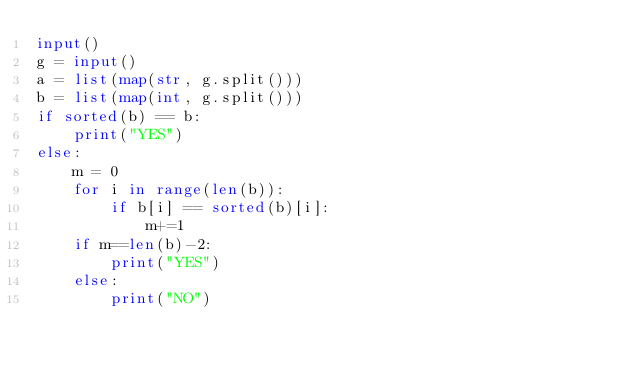<code> <loc_0><loc_0><loc_500><loc_500><_Python_>input()
g = input()
a = list(map(str, g.split()))
b = list(map(int, g.split()))
if sorted(b) == b:
    print("YES")
else:
    m = 0
    for i in range(len(b)):
        if b[i] == sorted(b)[i]:
            m+=1
    if m==len(b)-2:
        print("YES")
    else:
        print("NO")</code> 